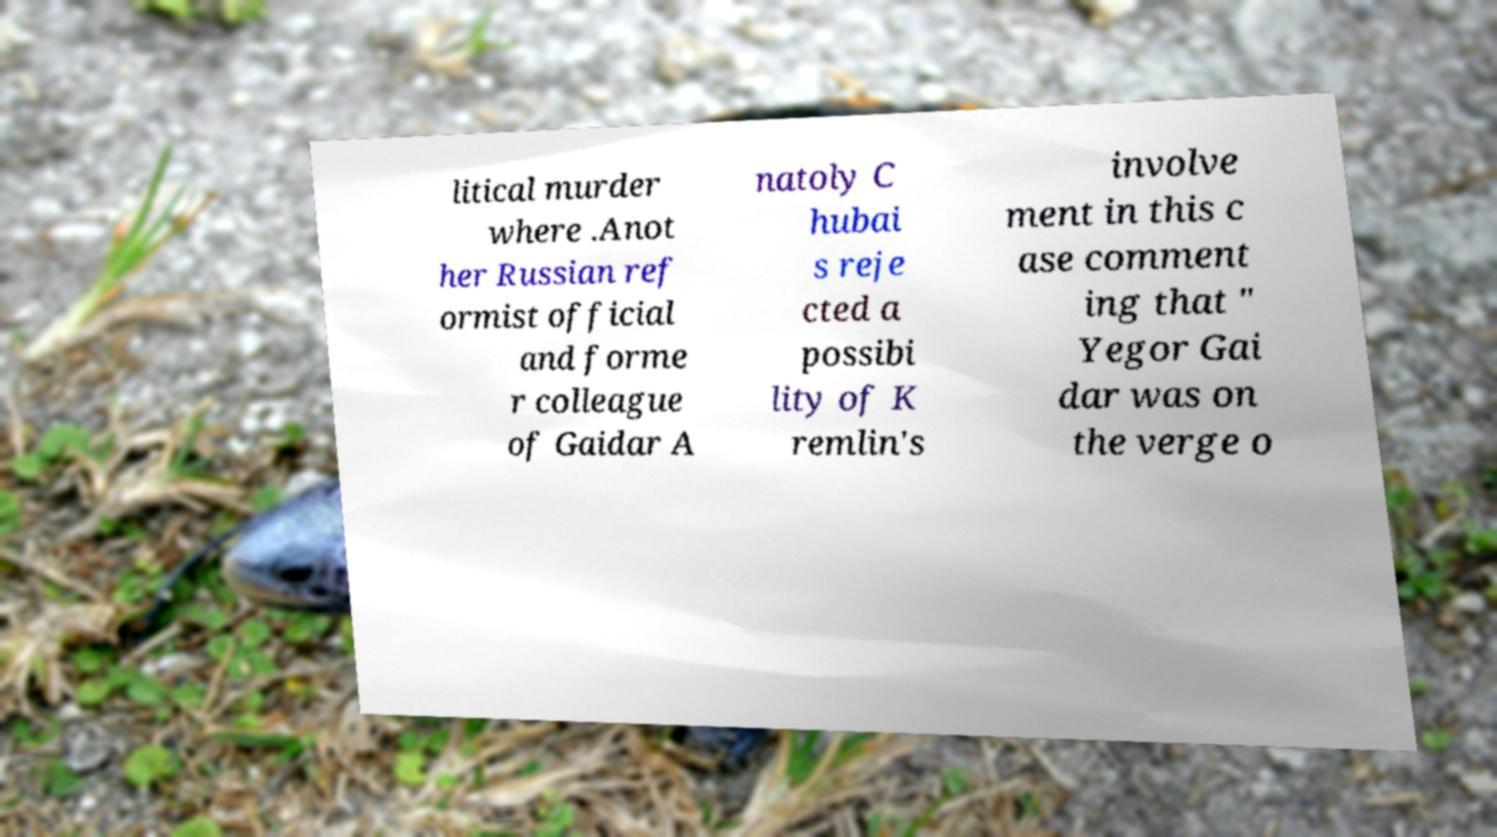Can you accurately transcribe the text from the provided image for me? litical murder where .Anot her Russian ref ormist official and forme r colleague of Gaidar A natoly C hubai s reje cted a possibi lity of K remlin's involve ment in this c ase comment ing that " Yegor Gai dar was on the verge o 